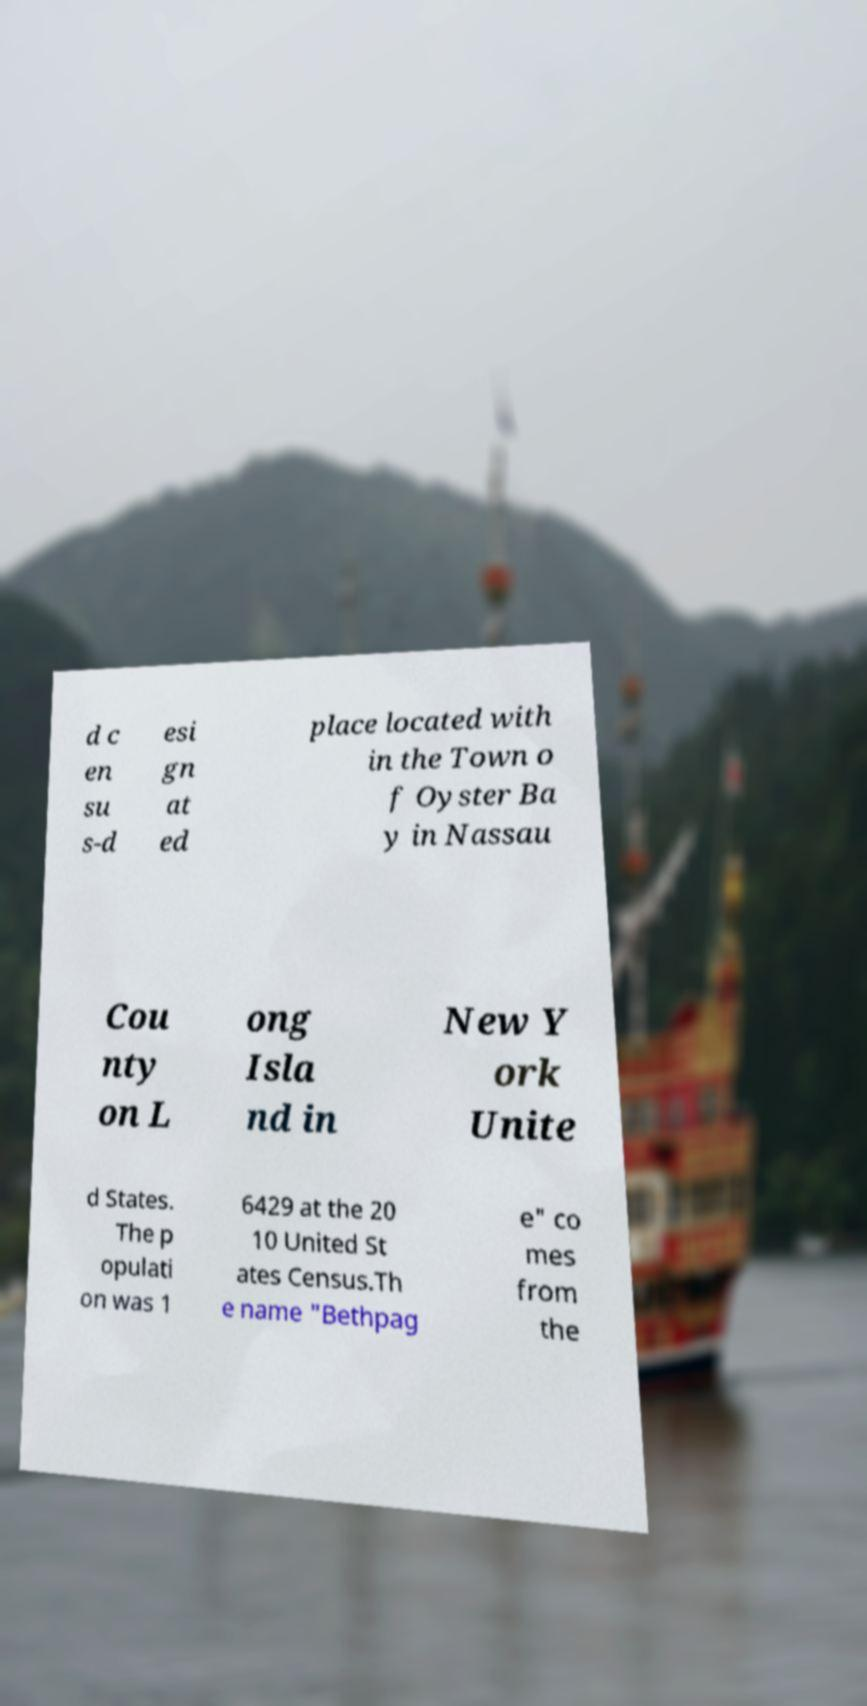I need the written content from this picture converted into text. Can you do that? d c en su s-d esi gn at ed place located with in the Town o f Oyster Ba y in Nassau Cou nty on L ong Isla nd in New Y ork Unite d States. The p opulati on was 1 6429 at the 20 10 United St ates Census.Th e name "Bethpag e" co mes from the 